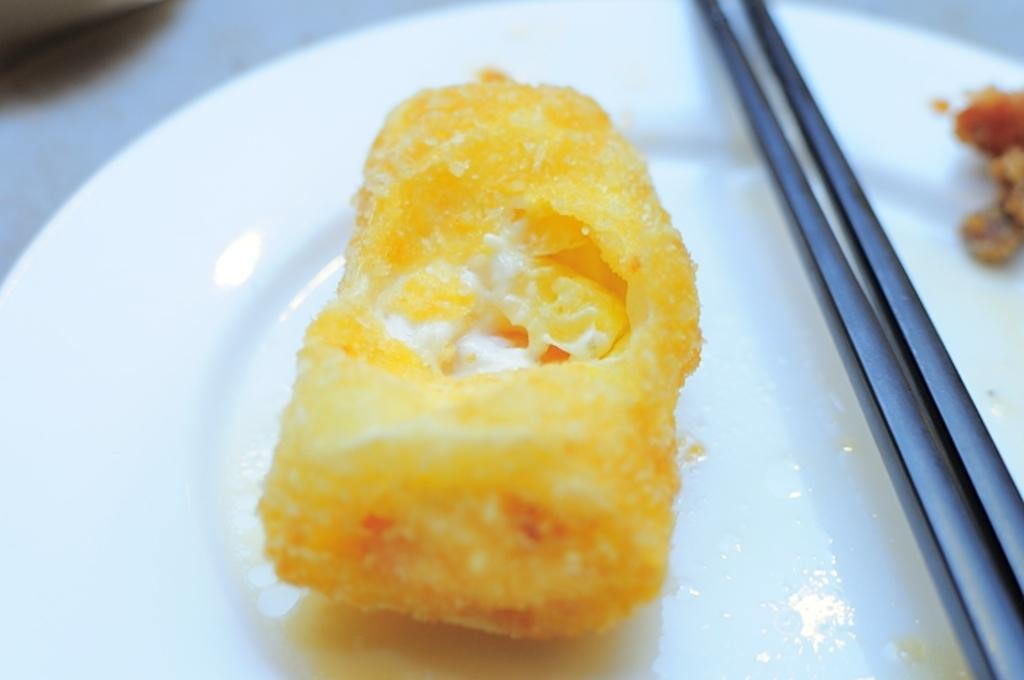What object is present in the image that is typically used for serving food? There is a plate in the image that is typically used for serving food. What is on the plate in the image? The plate contains a food item. What utensil is visible in the image? There are chopsticks in the image. How many balloons are floating above the plate in the image? There are no balloons present in the image. What type of appliance is used to prepare the food on the plate in the image? The provided facts do not mention any appliances used to prepare the food on the plate. 